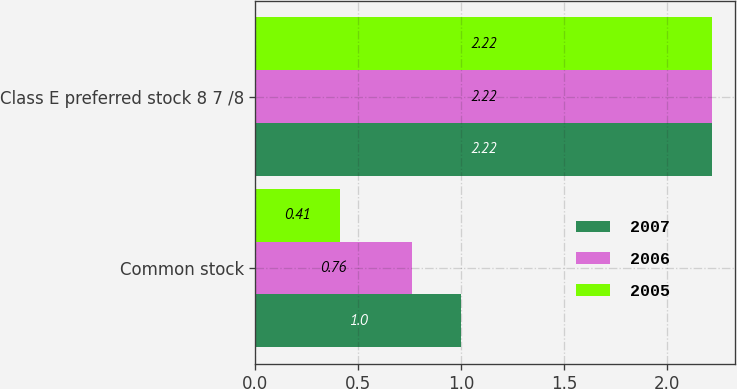<chart> <loc_0><loc_0><loc_500><loc_500><stacked_bar_chart><ecel><fcel>Common stock<fcel>Class E preferred stock 8 7 /8<nl><fcel>2007<fcel>1<fcel>2.22<nl><fcel>2006<fcel>0.76<fcel>2.22<nl><fcel>2005<fcel>0.41<fcel>2.22<nl></chart> 